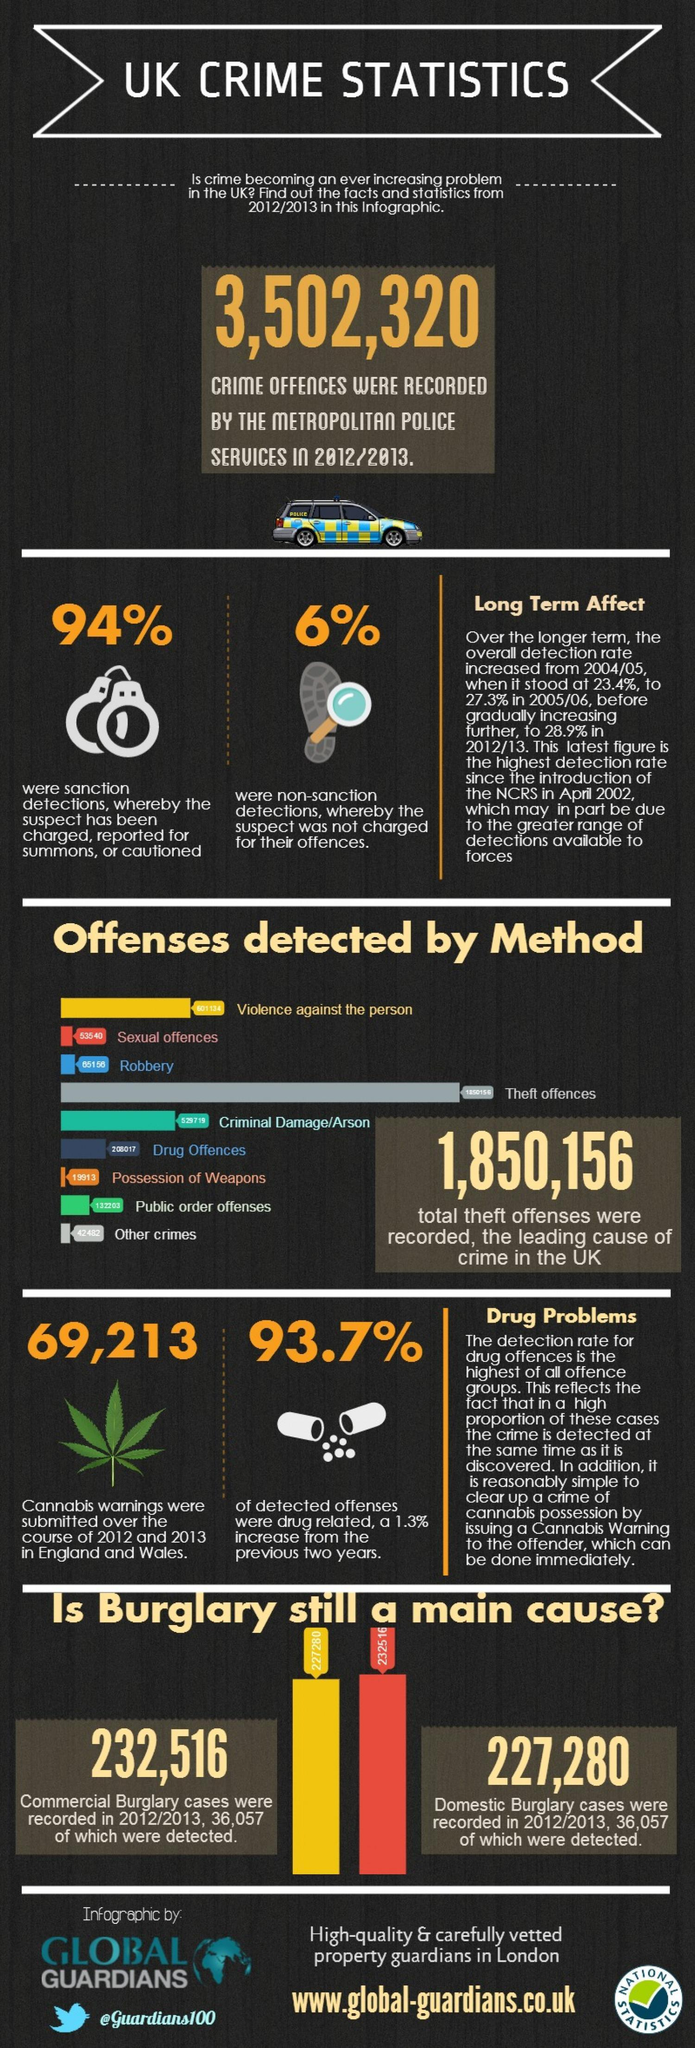Which crime is highlighted with red color, Robbery, Violence, or Sexual Offences ?
Answer the question with a short phrase. Sexual Offences Which color depicts the robbery offences, gray/ grey, blue, or green? blue What percentage of detected offenses were not drug related? 6.3% What is the total number of commercial and domestic burglaries reported in 2012-13? 459,796 How much more commercial burglary cases were reported in 2012/13 in comparison to domestic burglary cases? 5,236 